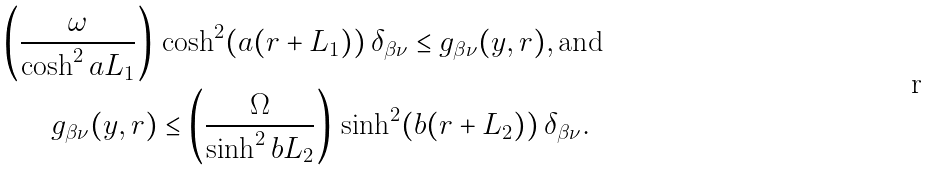Convert formula to latex. <formula><loc_0><loc_0><loc_500><loc_500>\left ( \frac { \omega } { \cosh ^ { 2 } { a L _ { 1 } } } \right ) \, & \cosh ^ { 2 } ( a ( r + L _ { 1 } ) ) \, \delta _ { \beta \nu } \leq g _ { \beta \nu } ( y , r ) , \text {and } \\ g _ { \beta \nu } ( y , r ) & \leq \left ( \frac { \Omega } { \sinh ^ { 2 } { b L _ { 2 } } } \right ) \, \sinh ^ { 2 } ( b ( r + L _ { 2 } ) ) \, \delta _ { \beta \nu } .</formula> 